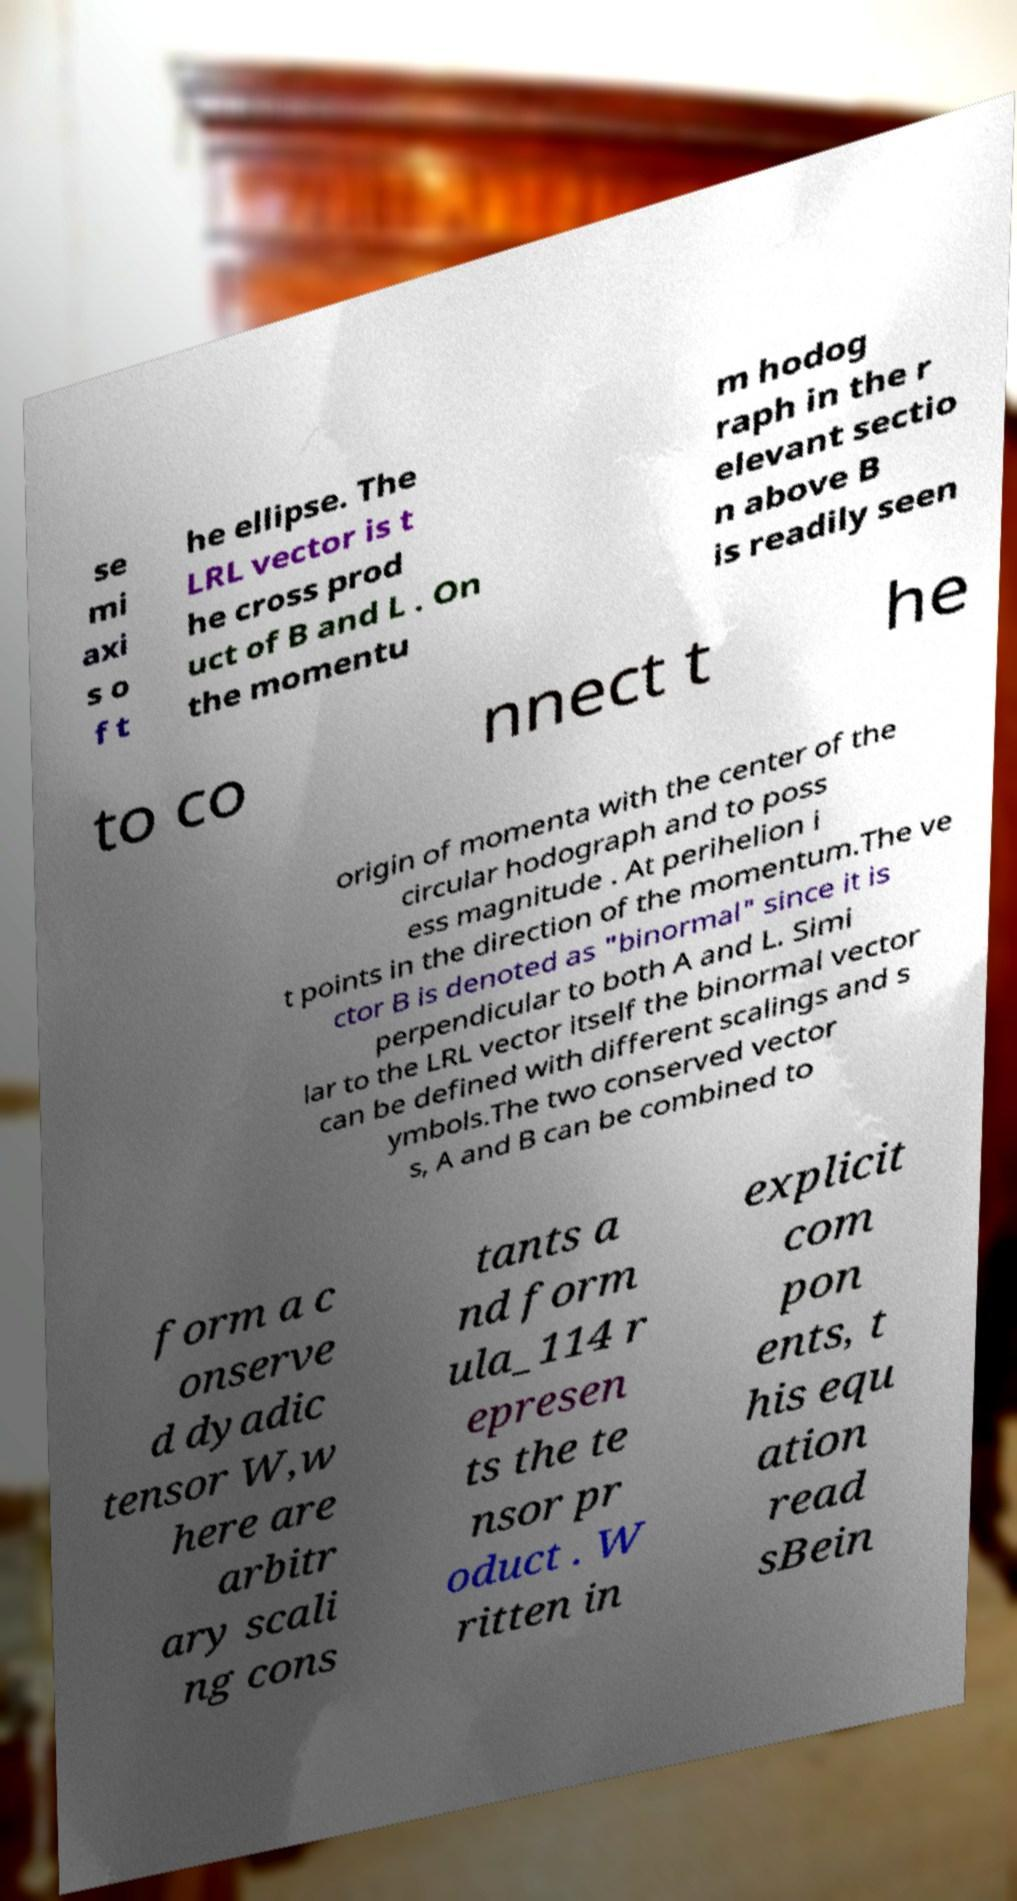I need the written content from this picture converted into text. Can you do that? se mi axi s o f t he ellipse. The LRL vector is t he cross prod uct of B and L . On the momentu m hodog raph in the r elevant sectio n above B is readily seen to co nnect t he origin of momenta with the center of the circular hodograph and to poss ess magnitude . At perihelion i t points in the direction of the momentum.The ve ctor B is denoted as "binormal" since it is perpendicular to both A and L. Simi lar to the LRL vector itself the binormal vector can be defined with different scalings and s ymbols.The two conserved vector s, A and B can be combined to form a c onserve d dyadic tensor W,w here are arbitr ary scali ng cons tants a nd form ula_114 r epresen ts the te nsor pr oduct . W ritten in explicit com pon ents, t his equ ation read sBein 